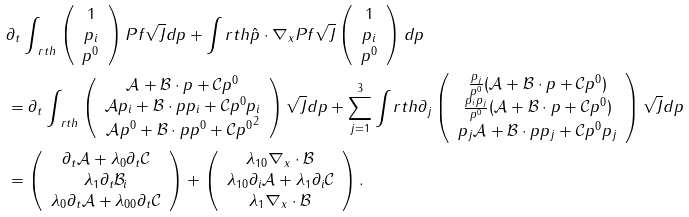<formula> <loc_0><loc_0><loc_500><loc_500>& \partial _ { t } \int _ { \ r t h } \left ( \begin{array} { c } 1 \\ p _ { i } \\ { p ^ { 0 } } \end{array} \right ) P f \sqrt { J } d p + \int _ { \ } r t h \hat { p } \cdot \nabla _ { x } P f \sqrt { J } \left ( \begin{array} { c } 1 \\ p _ { i } \\ { p ^ { 0 } } \end{array} \right ) d p \\ & = \partial _ { t } \int _ { \ r t h } \left ( \begin{array} { c } \mathcal { A } + \mathcal { B } \cdot p + \mathcal { C } { p ^ { 0 } } \\ \mathcal { A } p _ { i } + \mathcal { B } \cdot p p _ { i } + \mathcal { C } { p ^ { 0 } } p _ { i } \\ \mathcal { A } { p ^ { 0 } } + \mathcal { B } \cdot p { p ^ { 0 } } + \mathcal { C } { p ^ { 0 } } ^ { 2 } \end{array} \right ) \sqrt { J } d p + \sum _ { j = 1 } ^ { 3 } \int _ { \ } r t h \partial _ { j } \left ( \begin{array} { c } \frac { p _ { j } } { p ^ { 0 } } ( \mathcal { A } + \mathcal { B } \cdot p + \mathcal { C } { p ^ { 0 } } ) \\ \frac { p _ { i } p _ { j } } { p ^ { 0 } } ( \mathcal { A } + \mathcal { B } \cdot p + \mathcal { C } { p ^ { 0 } } ) \\ p _ { j } \mathcal { A } + \mathcal { B } \cdot p p _ { j } + \mathcal { C } { p ^ { 0 } } p _ { j } \end{array} \right ) \sqrt { J } d p \\ & = \left ( \begin{array} { c } \partial _ { t } \mathcal { A } + \lambda _ { 0 } \partial _ { t } \mathcal { C } \\ \lambda _ { 1 } \partial _ { t } \mathcal { B } _ { i } \\ \lambda _ { 0 } \partial _ { t } \mathcal { A } + \lambda _ { 0 0 } \partial _ { t } \mathcal { C } \end{array} \right ) + \left ( \begin{array} { c } \lambda _ { 1 0 } \nabla _ { x } \cdot \mathcal { B } \\ \lambda _ { 1 0 } \partial _ { i } \mathcal { A } + \lambda _ { 1 } \partial _ { i } \mathcal { C } \\ \lambda _ { 1 } \nabla _ { x } \cdot \mathcal { B } \end{array} \right ) . \\</formula> 